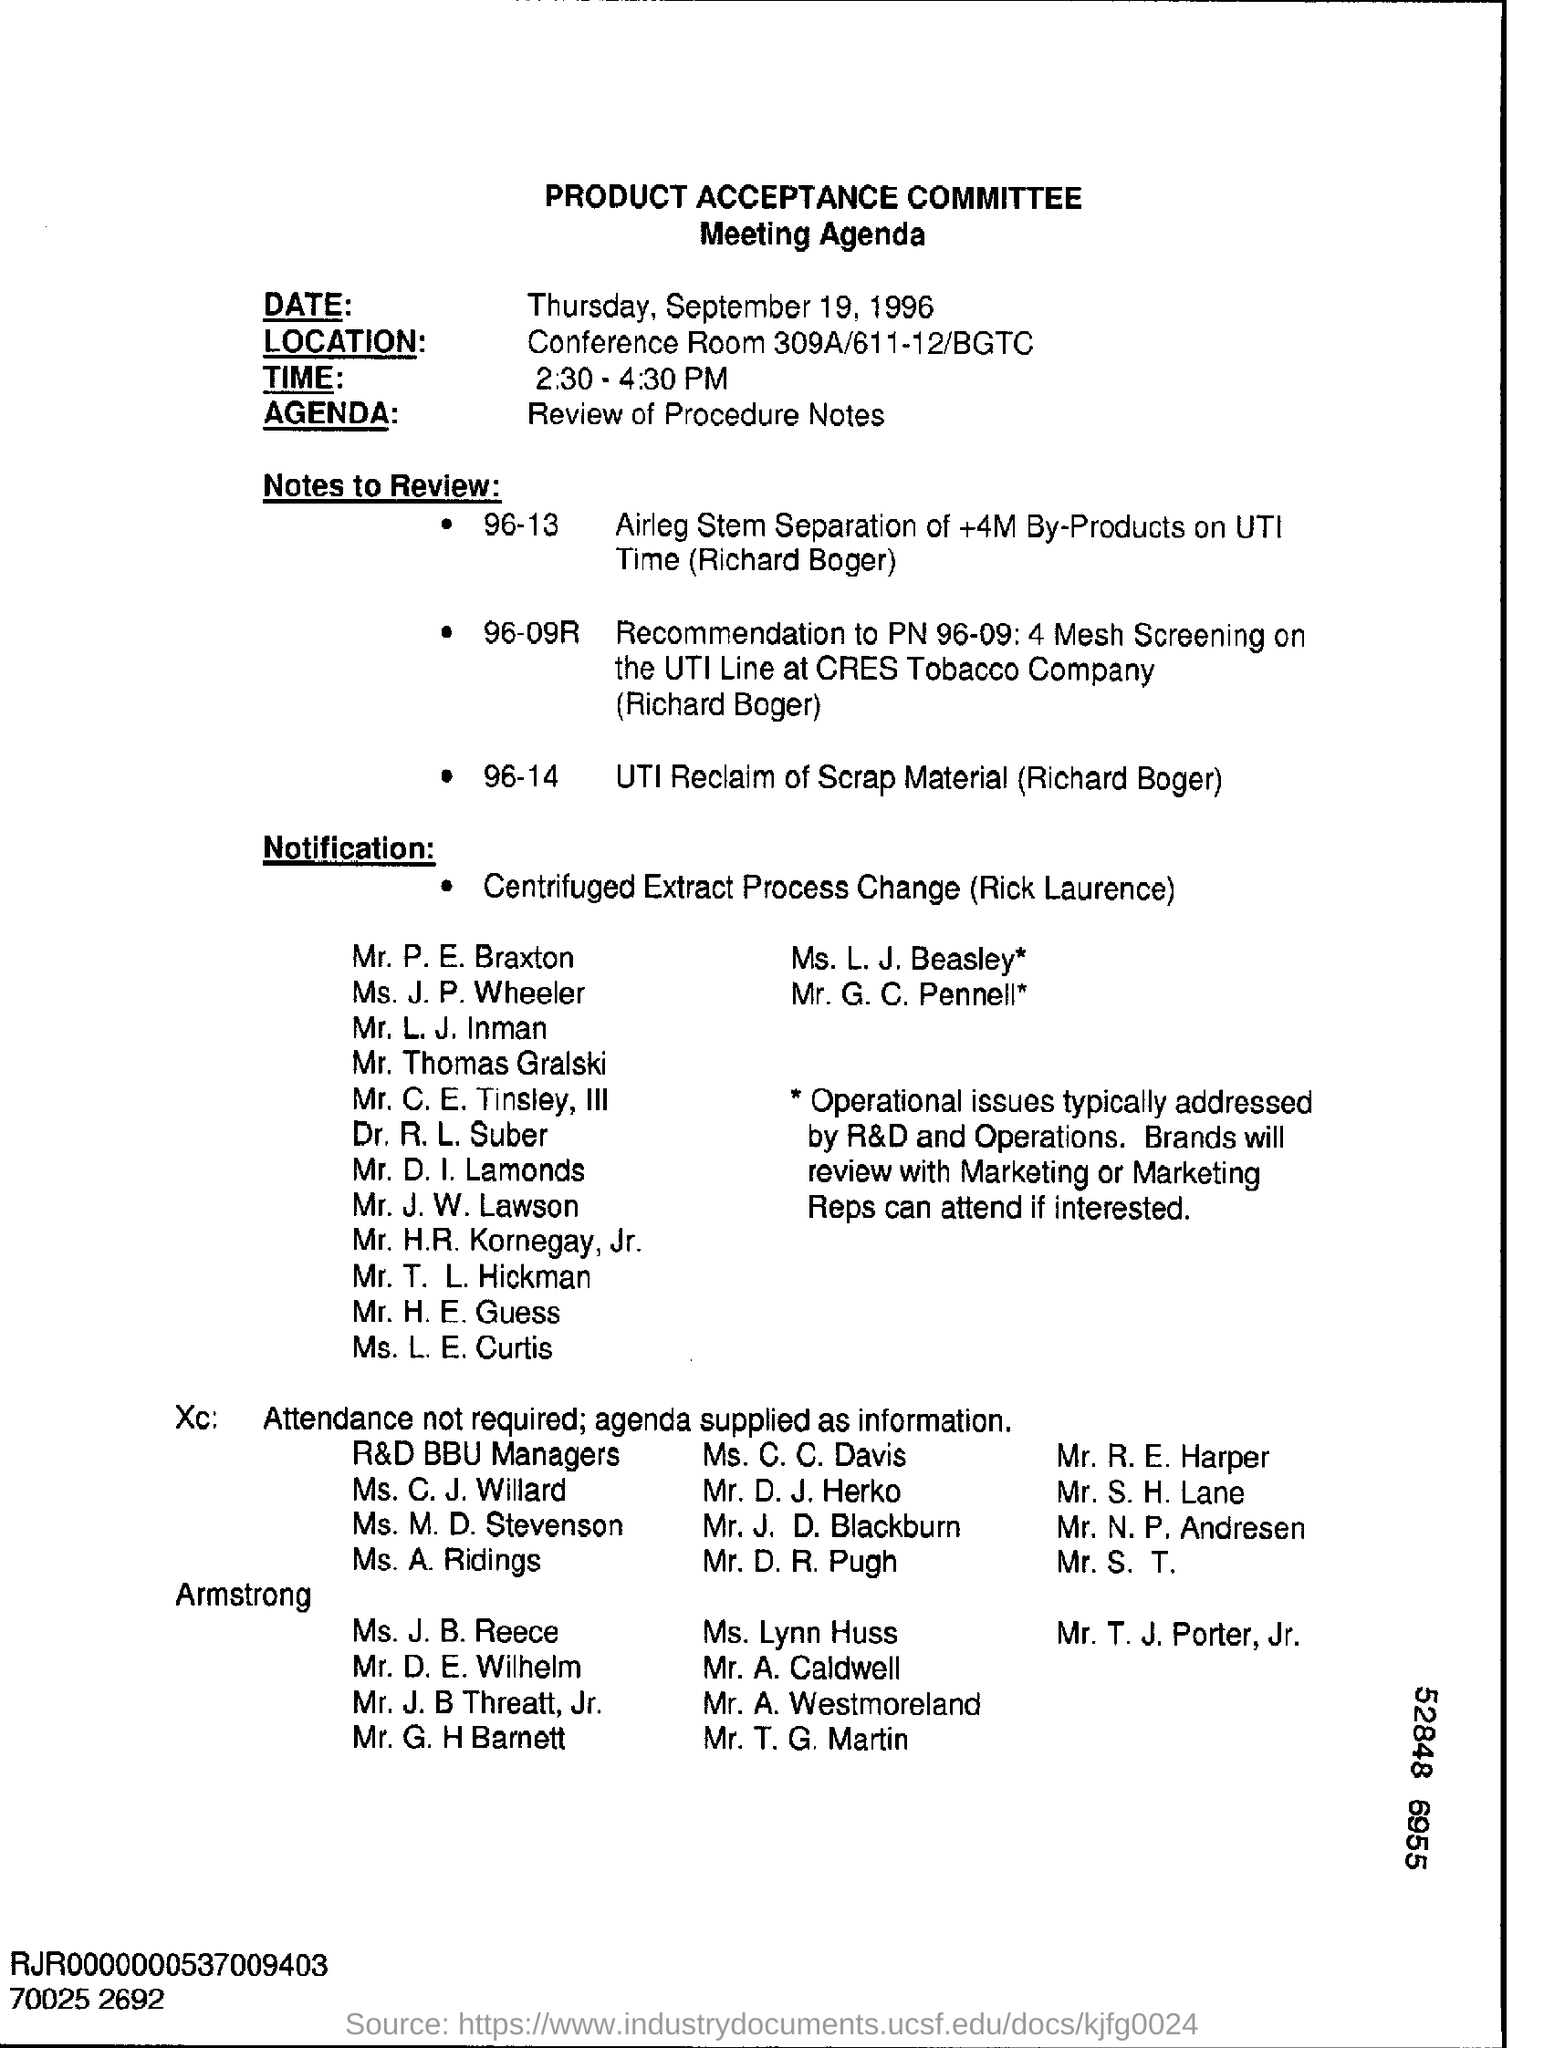What is the agenda of the meeting?
Make the answer very short. Review of Procedure Notes. What is written in the Agenda Field ?
Offer a terse response. Review of procedure notes. 